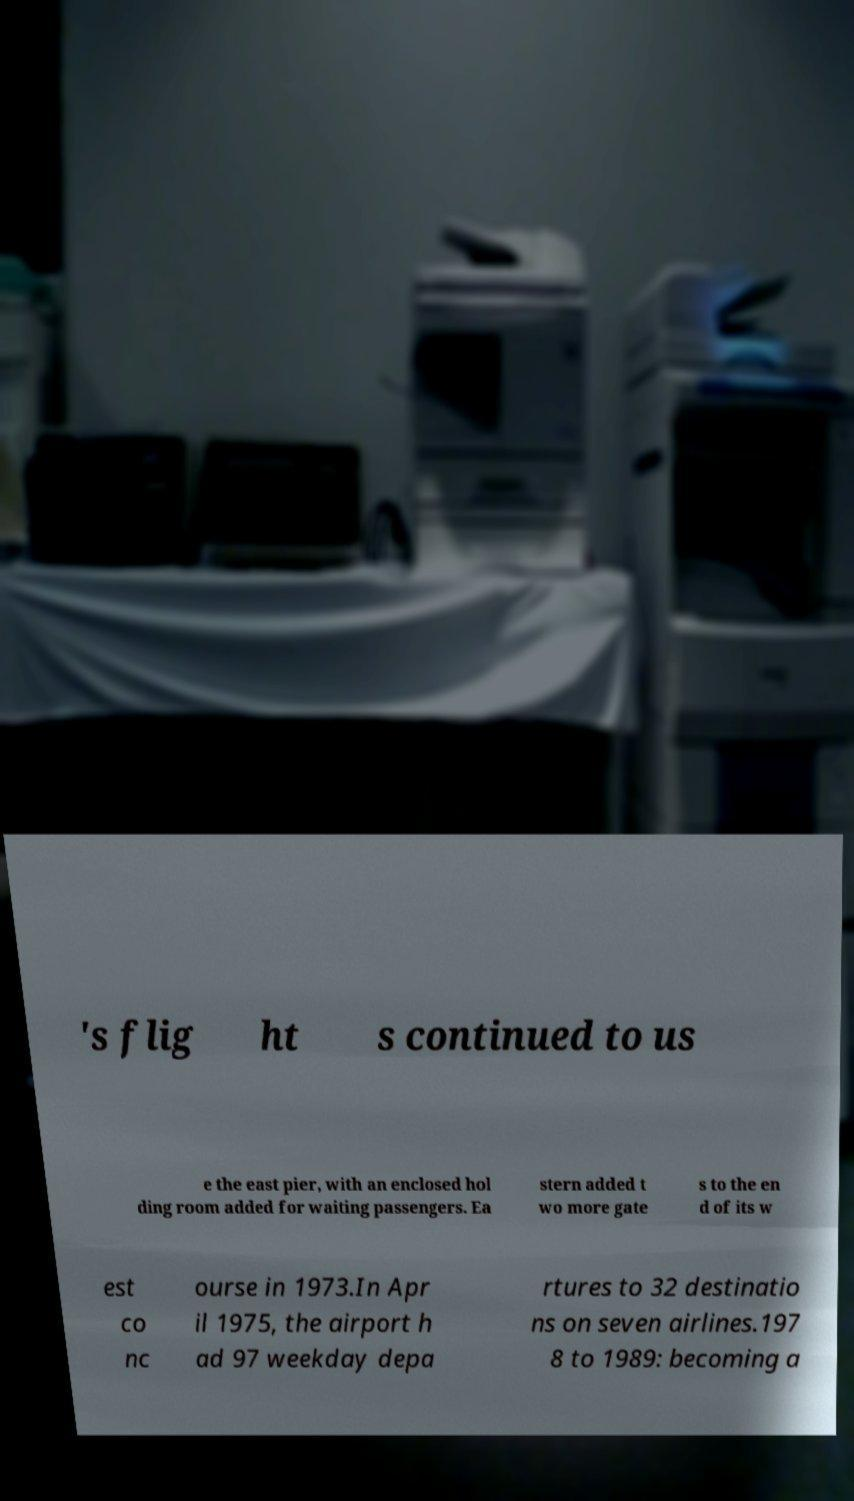Please read and relay the text visible in this image. What does it say? 's flig ht s continued to us e the east pier, with an enclosed hol ding room added for waiting passengers. Ea stern added t wo more gate s to the en d of its w est co nc ourse in 1973.In Apr il 1975, the airport h ad 97 weekday depa rtures to 32 destinatio ns on seven airlines.197 8 to 1989: becoming a 